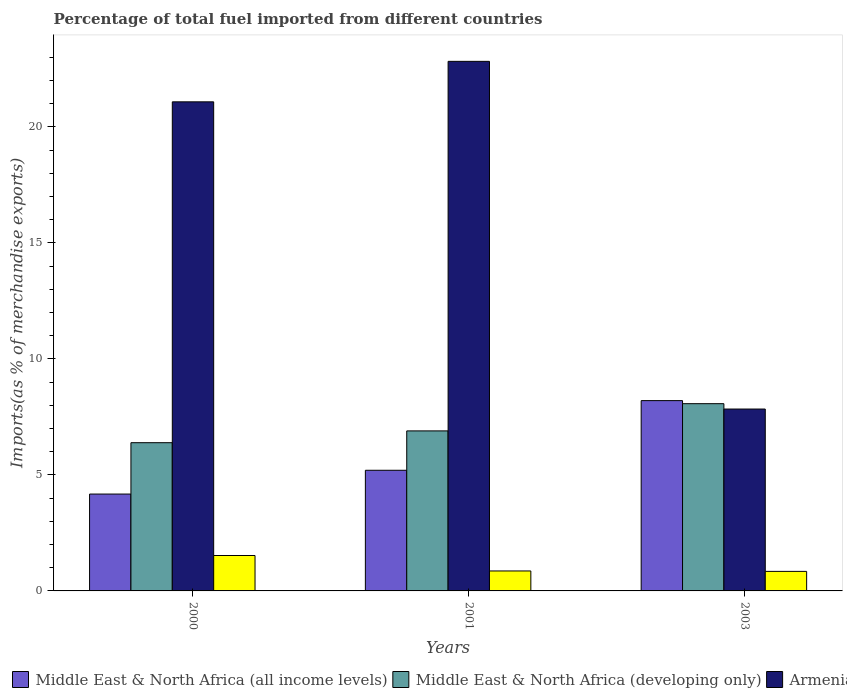How many different coloured bars are there?
Offer a very short reply. 4. Are the number of bars per tick equal to the number of legend labels?
Make the answer very short. Yes. Are the number of bars on each tick of the X-axis equal?
Offer a very short reply. Yes. How many bars are there on the 1st tick from the right?
Give a very brief answer. 4. What is the percentage of imports to different countries in Armenia in 2000?
Your answer should be compact. 21.08. Across all years, what is the maximum percentage of imports to different countries in Middle East & North Africa (all income levels)?
Ensure brevity in your answer.  8.2. Across all years, what is the minimum percentage of imports to different countries in Armenia?
Provide a succinct answer. 7.84. What is the total percentage of imports to different countries in Eritrea in the graph?
Your response must be concise. 3.23. What is the difference between the percentage of imports to different countries in Middle East & North Africa (developing only) in 2000 and that in 2001?
Your answer should be compact. -0.51. What is the difference between the percentage of imports to different countries in Armenia in 2000 and the percentage of imports to different countries in Eritrea in 2001?
Offer a very short reply. 20.22. What is the average percentage of imports to different countries in Middle East & North Africa (all income levels) per year?
Keep it short and to the point. 5.86. In the year 2000, what is the difference between the percentage of imports to different countries in Eritrea and percentage of imports to different countries in Middle East & North Africa (all income levels)?
Ensure brevity in your answer.  -2.65. In how many years, is the percentage of imports to different countries in Middle East & North Africa (developing only) greater than 10 %?
Give a very brief answer. 0. What is the ratio of the percentage of imports to different countries in Armenia in 2000 to that in 2003?
Keep it short and to the point. 2.69. Is the percentage of imports to different countries in Eritrea in 2000 less than that in 2001?
Give a very brief answer. No. Is the difference between the percentage of imports to different countries in Eritrea in 2001 and 2003 greater than the difference between the percentage of imports to different countries in Middle East & North Africa (all income levels) in 2001 and 2003?
Give a very brief answer. Yes. What is the difference between the highest and the second highest percentage of imports to different countries in Armenia?
Your answer should be compact. 1.74. What is the difference between the highest and the lowest percentage of imports to different countries in Middle East & North Africa (developing only)?
Make the answer very short. 1.68. In how many years, is the percentage of imports to different countries in Eritrea greater than the average percentage of imports to different countries in Eritrea taken over all years?
Give a very brief answer. 1. Is it the case that in every year, the sum of the percentage of imports to different countries in Middle East & North Africa (developing only) and percentage of imports to different countries in Middle East & North Africa (all income levels) is greater than the sum of percentage of imports to different countries in Armenia and percentage of imports to different countries in Eritrea?
Give a very brief answer. No. What does the 2nd bar from the left in 2001 represents?
Provide a short and direct response. Middle East & North Africa (developing only). What does the 1st bar from the right in 2003 represents?
Provide a short and direct response. Eritrea. Is it the case that in every year, the sum of the percentage of imports to different countries in Armenia and percentage of imports to different countries in Middle East & North Africa (all income levels) is greater than the percentage of imports to different countries in Middle East & North Africa (developing only)?
Make the answer very short. Yes. How many bars are there?
Provide a short and direct response. 12. Are all the bars in the graph horizontal?
Provide a short and direct response. No. How many years are there in the graph?
Your response must be concise. 3. What is the difference between two consecutive major ticks on the Y-axis?
Ensure brevity in your answer.  5. Does the graph contain any zero values?
Offer a terse response. No. How are the legend labels stacked?
Offer a very short reply. Horizontal. What is the title of the graph?
Keep it short and to the point. Percentage of total fuel imported from different countries. What is the label or title of the Y-axis?
Keep it short and to the point. Imports(as % of merchandise exports). What is the Imports(as % of merchandise exports) of Middle East & North Africa (all income levels) in 2000?
Your response must be concise. 4.17. What is the Imports(as % of merchandise exports) in Middle East & North Africa (developing only) in 2000?
Offer a very short reply. 6.39. What is the Imports(as % of merchandise exports) of Armenia in 2000?
Give a very brief answer. 21.08. What is the Imports(as % of merchandise exports) of Eritrea in 2000?
Keep it short and to the point. 1.53. What is the Imports(as % of merchandise exports) of Middle East & North Africa (all income levels) in 2001?
Your answer should be very brief. 5.2. What is the Imports(as % of merchandise exports) in Middle East & North Africa (developing only) in 2001?
Your response must be concise. 6.9. What is the Imports(as % of merchandise exports) of Armenia in 2001?
Provide a short and direct response. 22.82. What is the Imports(as % of merchandise exports) in Eritrea in 2001?
Your response must be concise. 0.86. What is the Imports(as % of merchandise exports) of Middle East & North Africa (all income levels) in 2003?
Offer a very short reply. 8.2. What is the Imports(as % of merchandise exports) in Middle East & North Africa (developing only) in 2003?
Provide a succinct answer. 8.07. What is the Imports(as % of merchandise exports) in Armenia in 2003?
Keep it short and to the point. 7.84. What is the Imports(as % of merchandise exports) of Eritrea in 2003?
Offer a very short reply. 0.84. Across all years, what is the maximum Imports(as % of merchandise exports) of Middle East & North Africa (all income levels)?
Keep it short and to the point. 8.2. Across all years, what is the maximum Imports(as % of merchandise exports) of Middle East & North Africa (developing only)?
Ensure brevity in your answer.  8.07. Across all years, what is the maximum Imports(as % of merchandise exports) in Armenia?
Your answer should be very brief. 22.82. Across all years, what is the maximum Imports(as % of merchandise exports) in Eritrea?
Your answer should be very brief. 1.53. Across all years, what is the minimum Imports(as % of merchandise exports) in Middle East & North Africa (all income levels)?
Keep it short and to the point. 4.17. Across all years, what is the minimum Imports(as % of merchandise exports) in Middle East & North Africa (developing only)?
Offer a terse response. 6.39. Across all years, what is the minimum Imports(as % of merchandise exports) in Armenia?
Make the answer very short. 7.84. Across all years, what is the minimum Imports(as % of merchandise exports) of Eritrea?
Provide a short and direct response. 0.84. What is the total Imports(as % of merchandise exports) of Middle East & North Africa (all income levels) in the graph?
Provide a short and direct response. 17.58. What is the total Imports(as % of merchandise exports) in Middle East & North Africa (developing only) in the graph?
Your answer should be very brief. 21.35. What is the total Imports(as % of merchandise exports) of Armenia in the graph?
Offer a terse response. 51.74. What is the total Imports(as % of merchandise exports) of Eritrea in the graph?
Your response must be concise. 3.23. What is the difference between the Imports(as % of merchandise exports) in Middle East & North Africa (all income levels) in 2000 and that in 2001?
Provide a short and direct response. -1.03. What is the difference between the Imports(as % of merchandise exports) in Middle East & North Africa (developing only) in 2000 and that in 2001?
Your answer should be very brief. -0.51. What is the difference between the Imports(as % of merchandise exports) of Armenia in 2000 and that in 2001?
Make the answer very short. -1.74. What is the difference between the Imports(as % of merchandise exports) in Eritrea in 2000 and that in 2001?
Keep it short and to the point. 0.67. What is the difference between the Imports(as % of merchandise exports) in Middle East & North Africa (all income levels) in 2000 and that in 2003?
Give a very brief answer. -4.03. What is the difference between the Imports(as % of merchandise exports) of Middle East & North Africa (developing only) in 2000 and that in 2003?
Your response must be concise. -1.68. What is the difference between the Imports(as % of merchandise exports) in Armenia in 2000 and that in 2003?
Give a very brief answer. 13.24. What is the difference between the Imports(as % of merchandise exports) in Eritrea in 2000 and that in 2003?
Provide a succinct answer. 0.68. What is the difference between the Imports(as % of merchandise exports) of Middle East & North Africa (all income levels) in 2001 and that in 2003?
Your response must be concise. -3. What is the difference between the Imports(as % of merchandise exports) in Middle East & North Africa (developing only) in 2001 and that in 2003?
Your answer should be compact. -1.17. What is the difference between the Imports(as % of merchandise exports) in Armenia in 2001 and that in 2003?
Your response must be concise. 14.98. What is the difference between the Imports(as % of merchandise exports) of Eritrea in 2001 and that in 2003?
Ensure brevity in your answer.  0.02. What is the difference between the Imports(as % of merchandise exports) in Middle East & North Africa (all income levels) in 2000 and the Imports(as % of merchandise exports) in Middle East & North Africa (developing only) in 2001?
Your response must be concise. -2.72. What is the difference between the Imports(as % of merchandise exports) in Middle East & North Africa (all income levels) in 2000 and the Imports(as % of merchandise exports) in Armenia in 2001?
Your answer should be compact. -18.65. What is the difference between the Imports(as % of merchandise exports) of Middle East & North Africa (all income levels) in 2000 and the Imports(as % of merchandise exports) of Eritrea in 2001?
Your answer should be compact. 3.31. What is the difference between the Imports(as % of merchandise exports) of Middle East & North Africa (developing only) in 2000 and the Imports(as % of merchandise exports) of Armenia in 2001?
Your answer should be very brief. -16.43. What is the difference between the Imports(as % of merchandise exports) of Middle East & North Africa (developing only) in 2000 and the Imports(as % of merchandise exports) of Eritrea in 2001?
Offer a very short reply. 5.53. What is the difference between the Imports(as % of merchandise exports) in Armenia in 2000 and the Imports(as % of merchandise exports) in Eritrea in 2001?
Your answer should be compact. 20.22. What is the difference between the Imports(as % of merchandise exports) in Middle East & North Africa (all income levels) in 2000 and the Imports(as % of merchandise exports) in Middle East & North Africa (developing only) in 2003?
Give a very brief answer. -3.9. What is the difference between the Imports(as % of merchandise exports) in Middle East & North Africa (all income levels) in 2000 and the Imports(as % of merchandise exports) in Armenia in 2003?
Offer a terse response. -3.66. What is the difference between the Imports(as % of merchandise exports) of Middle East & North Africa (all income levels) in 2000 and the Imports(as % of merchandise exports) of Eritrea in 2003?
Offer a terse response. 3.33. What is the difference between the Imports(as % of merchandise exports) in Middle East & North Africa (developing only) in 2000 and the Imports(as % of merchandise exports) in Armenia in 2003?
Keep it short and to the point. -1.45. What is the difference between the Imports(as % of merchandise exports) in Middle East & North Africa (developing only) in 2000 and the Imports(as % of merchandise exports) in Eritrea in 2003?
Provide a short and direct response. 5.55. What is the difference between the Imports(as % of merchandise exports) of Armenia in 2000 and the Imports(as % of merchandise exports) of Eritrea in 2003?
Keep it short and to the point. 20.24. What is the difference between the Imports(as % of merchandise exports) of Middle East & North Africa (all income levels) in 2001 and the Imports(as % of merchandise exports) of Middle East & North Africa (developing only) in 2003?
Keep it short and to the point. -2.87. What is the difference between the Imports(as % of merchandise exports) of Middle East & North Africa (all income levels) in 2001 and the Imports(as % of merchandise exports) of Armenia in 2003?
Provide a short and direct response. -2.64. What is the difference between the Imports(as % of merchandise exports) in Middle East & North Africa (all income levels) in 2001 and the Imports(as % of merchandise exports) in Eritrea in 2003?
Provide a succinct answer. 4.36. What is the difference between the Imports(as % of merchandise exports) of Middle East & North Africa (developing only) in 2001 and the Imports(as % of merchandise exports) of Armenia in 2003?
Keep it short and to the point. -0.94. What is the difference between the Imports(as % of merchandise exports) of Middle East & North Africa (developing only) in 2001 and the Imports(as % of merchandise exports) of Eritrea in 2003?
Offer a very short reply. 6.05. What is the difference between the Imports(as % of merchandise exports) in Armenia in 2001 and the Imports(as % of merchandise exports) in Eritrea in 2003?
Ensure brevity in your answer.  21.98. What is the average Imports(as % of merchandise exports) of Middle East & North Africa (all income levels) per year?
Your answer should be very brief. 5.86. What is the average Imports(as % of merchandise exports) of Middle East & North Africa (developing only) per year?
Offer a terse response. 7.12. What is the average Imports(as % of merchandise exports) of Armenia per year?
Your response must be concise. 17.25. What is the average Imports(as % of merchandise exports) of Eritrea per year?
Provide a short and direct response. 1.08. In the year 2000, what is the difference between the Imports(as % of merchandise exports) of Middle East & North Africa (all income levels) and Imports(as % of merchandise exports) of Middle East & North Africa (developing only)?
Keep it short and to the point. -2.21. In the year 2000, what is the difference between the Imports(as % of merchandise exports) of Middle East & North Africa (all income levels) and Imports(as % of merchandise exports) of Armenia?
Provide a short and direct response. -16.9. In the year 2000, what is the difference between the Imports(as % of merchandise exports) of Middle East & North Africa (all income levels) and Imports(as % of merchandise exports) of Eritrea?
Keep it short and to the point. 2.65. In the year 2000, what is the difference between the Imports(as % of merchandise exports) in Middle East & North Africa (developing only) and Imports(as % of merchandise exports) in Armenia?
Your answer should be compact. -14.69. In the year 2000, what is the difference between the Imports(as % of merchandise exports) of Middle East & North Africa (developing only) and Imports(as % of merchandise exports) of Eritrea?
Your answer should be very brief. 4.86. In the year 2000, what is the difference between the Imports(as % of merchandise exports) in Armenia and Imports(as % of merchandise exports) in Eritrea?
Your answer should be very brief. 19.55. In the year 2001, what is the difference between the Imports(as % of merchandise exports) in Middle East & North Africa (all income levels) and Imports(as % of merchandise exports) in Middle East & North Africa (developing only)?
Provide a short and direct response. -1.7. In the year 2001, what is the difference between the Imports(as % of merchandise exports) in Middle East & North Africa (all income levels) and Imports(as % of merchandise exports) in Armenia?
Provide a succinct answer. -17.62. In the year 2001, what is the difference between the Imports(as % of merchandise exports) in Middle East & North Africa (all income levels) and Imports(as % of merchandise exports) in Eritrea?
Keep it short and to the point. 4.34. In the year 2001, what is the difference between the Imports(as % of merchandise exports) in Middle East & North Africa (developing only) and Imports(as % of merchandise exports) in Armenia?
Your response must be concise. -15.93. In the year 2001, what is the difference between the Imports(as % of merchandise exports) in Middle East & North Africa (developing only) and Imports(as % of merchandise exports) in Eritrea?
Provide a succinct answer. 6.04. In the year 2001, what is the difference between the Imports(as % of merchandise exports) of Armenia and Imports(as % of merchandise exports) of Eritrea?
Offer a terse response. 21.96. In the year 2003, what is the difference between the Imports(as % of merchandise exports) in Middle East & North Africa (all income levels) and Imports(as % of merchandise exports) in Middle East & North Africa (developing only)?
Make the answer very short. 0.13. In the year 2003, what is the difference between the Imports(as % of merchandise exports) of Middle East & North Africa (all income levels) and Imports(as % of merchandise exports) of Armenia?
Your response must be concise. 0.36. In the year 2003, what is the difference between the Imports(as % of merchandise exports) of Middle East & North Africa (all income levels) and Imports(as % of merchandise exports) of Eritrea?
Your response must be concise. 7.36. In the year 2003, what is the difference between the Imports(as % of merchandise exports) of Middle East & North Africa (developing only) and Imports(as % of merchandise exports) of Armenia?
Make the answer very short. 0.23. In the year 2003, what is the difference between the Imports(as % of merchandise exports) of Middle East & North Africa (developing only) and Imports(as % of merchandise exports) of Eritrea?
Offer a very short reply. 7.23. In the year 2003, what is the difference between the Imports(as % of merchandise exports) in Armenia and Imports(as % of merchandise exports) in Eritrea?
Provide a succinct answer. 7. What is the ratio of the Imports(as % of merchandise exports) in Middle East & North Africa (all income levels) in 2000 to that in 2001?
Provide a short and direct response. 0.8. What is the ratio of the Imports(as % of merchandise exports) in Middle East & North Africa (developing only) in 2000 to that in 2001?
Provide a succinct answer. 0.93. What is the ratio of the Imports(as % of merchandise exports) of Armenia in 2000 to that in 2001?
Your response must be concise. 0.92. What is the ratio of the Imports(as % of merchandise exports) of Eritrea in 2000 to that in 2001?
Offer a very short reply. 1.77. What is the ratio of the Imports(as % of merchandise exports) of Middle East & North Africa (all income levels) in 2000 to that in 2003?
Your response must be concise. 0.51. What is the ratio of the Imports(as % of merchandise exports) of Middle East & North Africa (developing only) in 2000 to that in 2003?
Offer a very short reply. 0.79. What is the ratio of the Imports(as % of merchandise exports) in Armenia in 2000 to that in 2003?
Provide a succinct answer. 2.69. What is the ratio of the Imports(as % of merchandise exports) in Eritrea in 2000 to that in 2003?
Provide a short and direct response. 1.81. What is the ratio of the Imports(as % of merchandise exports) of Middle East & North Africa (all income levels) in 2001 to that in 2003?
Keep it short and to the point. 0.63. What is the ratio of the Imports(as % of merchandise exports) in Middle East & North Africa (developing only) in 2001 to that in 2003?
Your answer should be very brief. 0.85. What is the ratio of the Imports(as % of merchandise exports) of Armenia in 2001 to that in 2003?
Keep it short and to the point. 2.91. What is the ratio of the Imports(as % of merchandise exports) in Eritrea in 2001 to that in 2003?
Ensure brevity in your answer.  1.02. What is the difference between the highest and the second highest Imports(as % of merchandise exports) of Middle East & North Africa (all income levels)?
Make the answer very short. 3. What is the difference between the highest and the second highest Imports(as % of merchandise exports) of Middle East & North Africa (developing only)?
Ensure brevity in your answer.  1.17. What is the difference between the highest and the second highest Imports(as % of merchandise exports) in Armenia?
Offer a very short reply. 1.74. What is the difference between the highest and the second highest Imports(as % of merchandise exports) of Eritrea?
Your answer should be compact. 0.67. What is the difference between the highest and the lowest Imports(as % of merchandise exports) of Middle East & North Africa (all income levels)?
Your answer should be compact. 4.03. What is the difference between the highest and the lowest Imports(as % of merchandise exports) in Middle East & North Africa (developing only)?
Provide a succinct answer. 1.68. What is the difference between the highest and the lowest Imports(as % of merchandise exports) of Armenia?
Give a very brief answer. 14.98. What is the difference between the highest and the lowest Imports(as % of merchandise exports) of Eritrea?
Offer a very short reply. 0.68. 